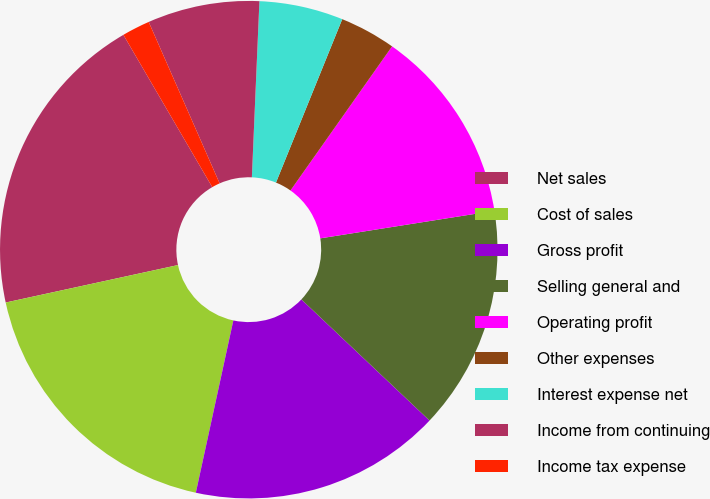Convert chart. <chart><loc_0><loc_0><loc_500><loc_500><pie_chart><fcel>Net sales<fcel>Cost of sales<fcel>Gross profit<fcel>Selling general and<fcel>Operating profit<fcel>Other expenses<fcel>Interest expense net<fcel>Income from continuing<fcel>Income tax expense<nl><fcel>20.0%<fcel>18.18%<fcel>16.36%<fcel>14.55%<fcel>12.73%<fcel>3.64%<fcel>5.45%<fcel>7.27%<fcel>1.82%<nl></chart> 